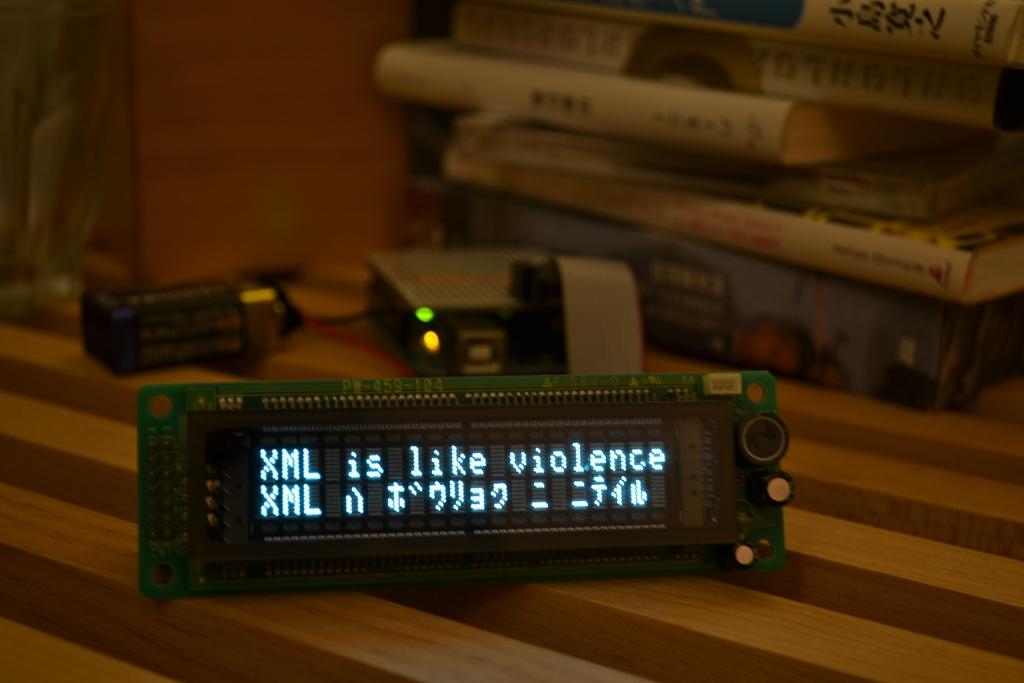<image>
Render a clear and concise summary of the photo. Screen showing words "XML" on it on a table. 